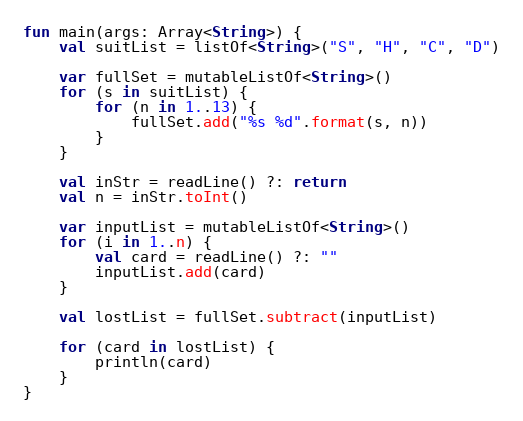Convert code to text. <code><loc_0><loc_0><loc_500><loc_500><_Kotlin_>fun main(args: Array<String>) {
    val suitList = listOf<String>("S", "H", "C", "D")

    var fullSet = mutableListOf<String>()
    for (s in suitList) {
        for (n in 1..13) {
            fullSet.add("%s %d".format(s, n))
        }
    }

    val inStr = readLine() ?: return
    val n = inStr.toInt()

    var inputList = mutableListOf<String>()
    for (i in 1..n) {
        val card = readLine() ?: ""
        inputList.add(card)
    }

    val lostList = fullSet.subtract(inputList)

    for (card in lostList) {
        println(card)
    }
}

</code> 